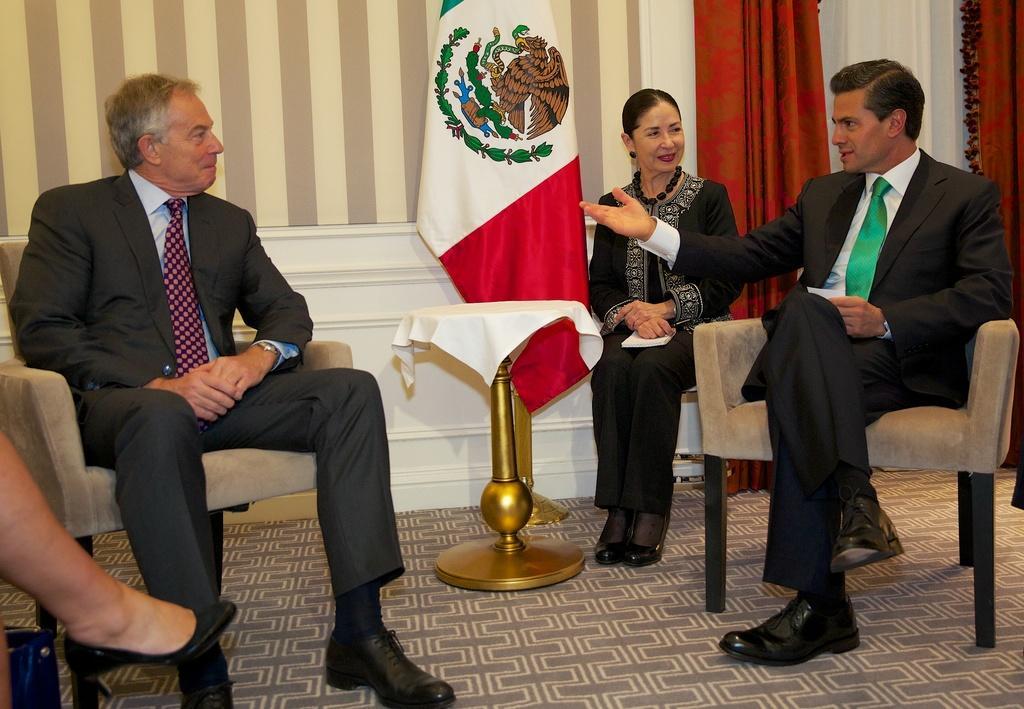Please provide a concise description of this image. In this image I can see few people sitting on the chair. I can see a stand and white cloth on it. Back I can see a flag and red color curtain. 